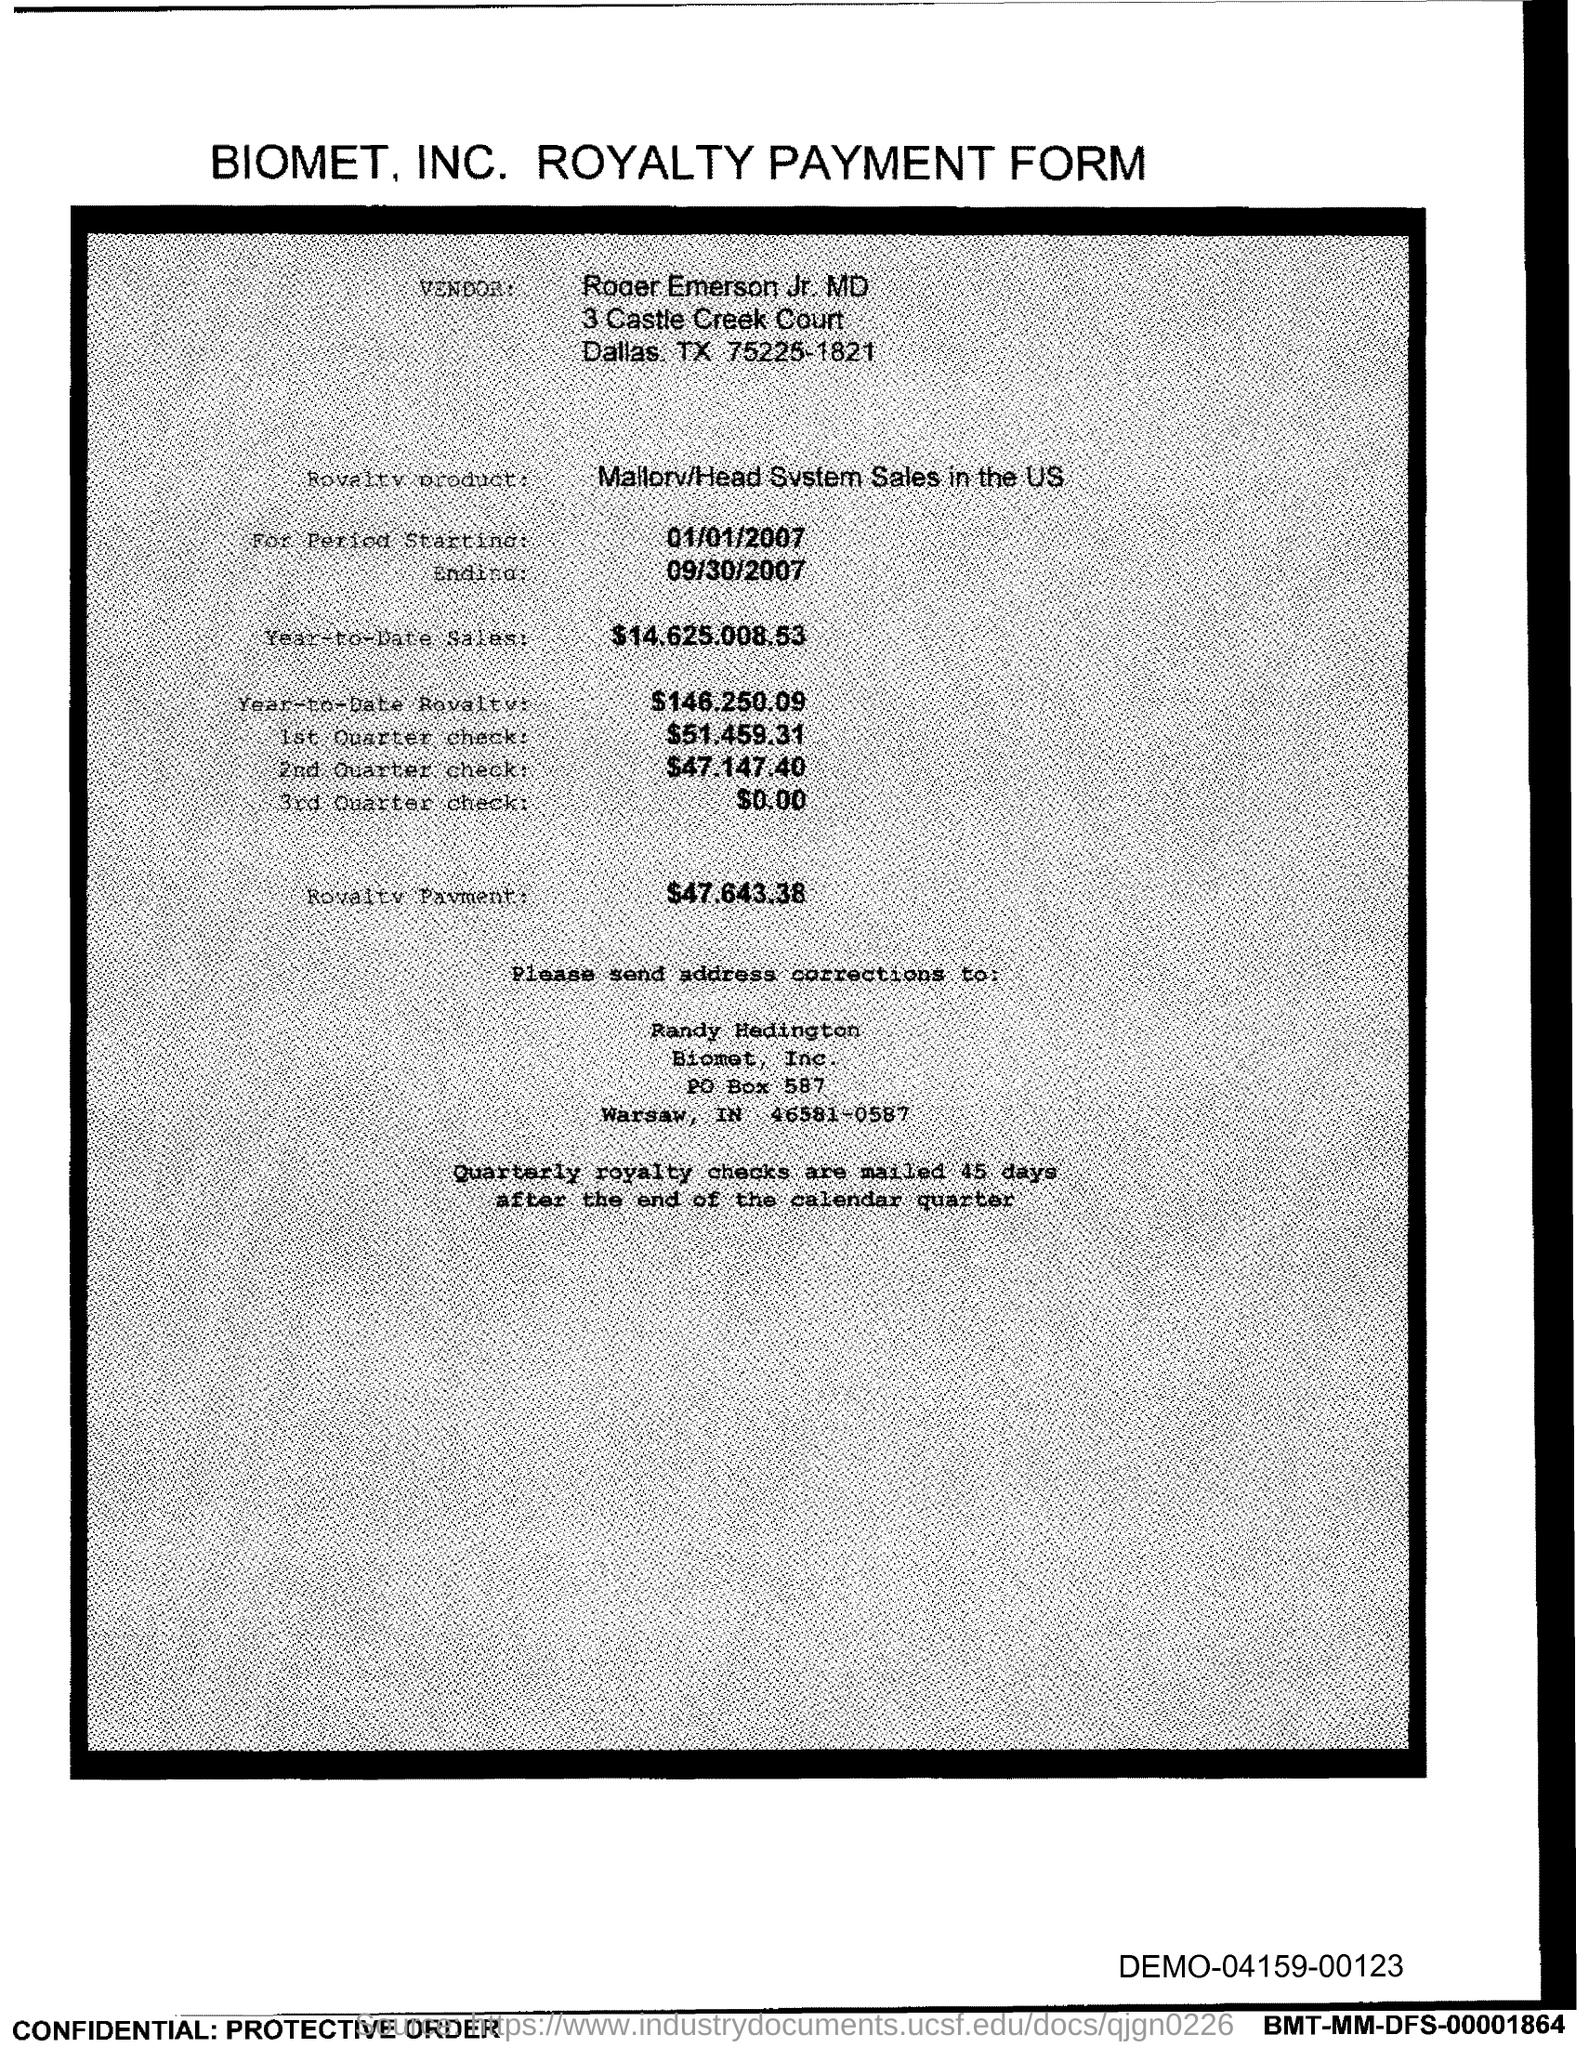How much is the total royalty payment for the period? The total royalty payment for the period is $47,643.38. 